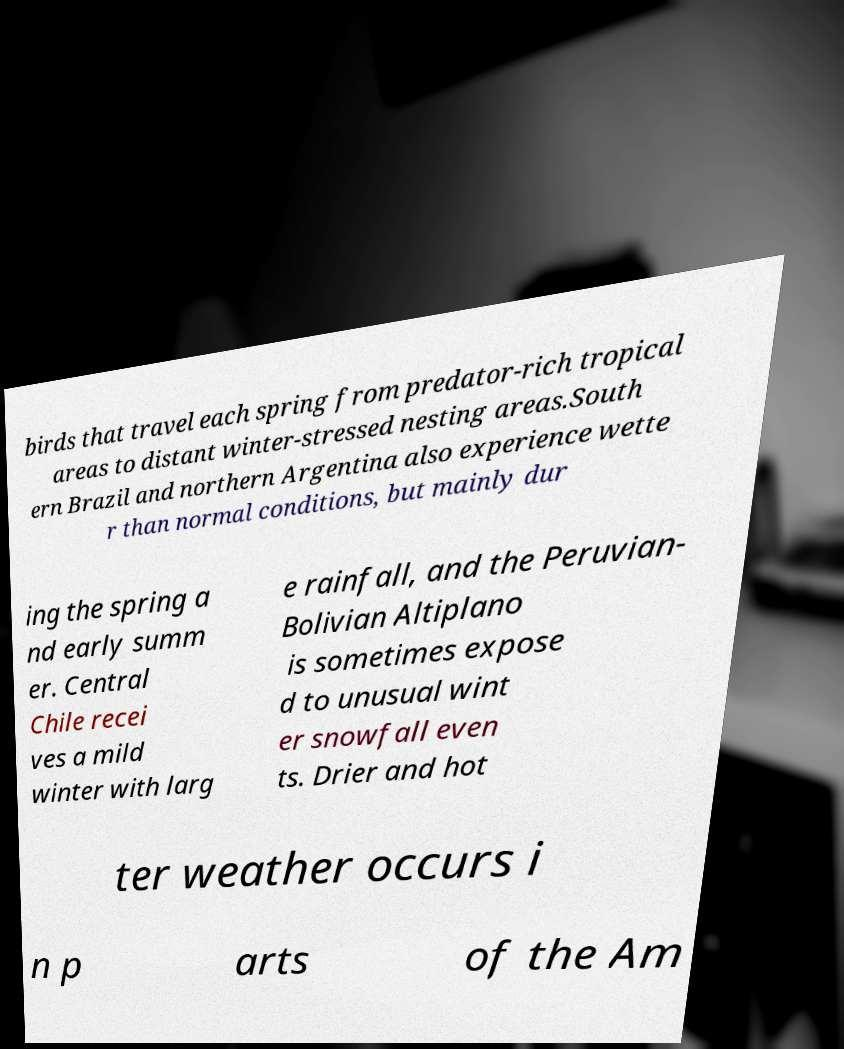What messages or text are displayed in this image? I need them in a readable, typed format. birds that travel each spring from predator-rich tropical areas to distant winter-stressed nesting areas.South ern Brazil and northern Argentina also experience wette r than normal conditions, but mainly dur ing the spring a nd early summ er. Central Chile recei ves a mild winter with larg e rainfall, and the Peruvian- Bolivian Altiplano is sometimes expose d to unusual wint er snowfall even ts. Drier and hot ter weather occurs i n p arts of the Am 